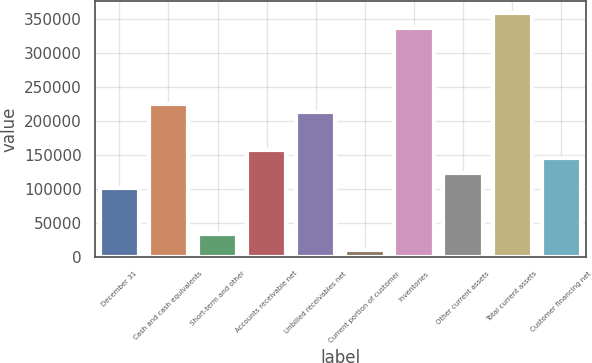<chart> <loc_0><loc_0><loc_500><loc_500><bar_chart><fcel>December 31<fcel>Cash and cash equivalents<fcel>Short-term and other<fcel>Accounts receivable net<fcel>Unbilled receivables net<fcel>Current portion of customer<fcel>Inventories<fcel>Other current assets<fcel>Total current assets<fcel>Customer financing net<nl><fcel>101132<fcel>224667<fcel>33748.5<fcel>157284<fcel>213436<fcel>11287.5<fcel>336972<fcel>123592<fcel>359433<fcel>146054<nl></chart> 